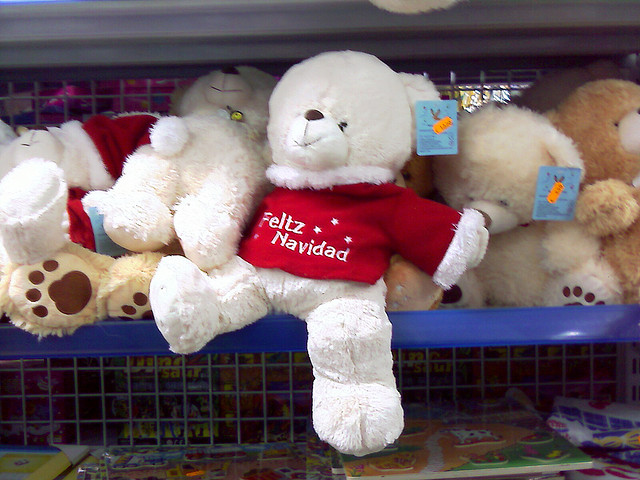What could be the occasion for this teddy bear in the red shirt? The teddy bear is dressed for the Christmas season, evidenced by the 'Feliz Navidad' shirt it's wearing, which in English means 'Merry Christmas.' This attire suggests it could make a festive gift during the holiday season or be part of a seasonal display to invoke the holiday spirit in shoppers. 